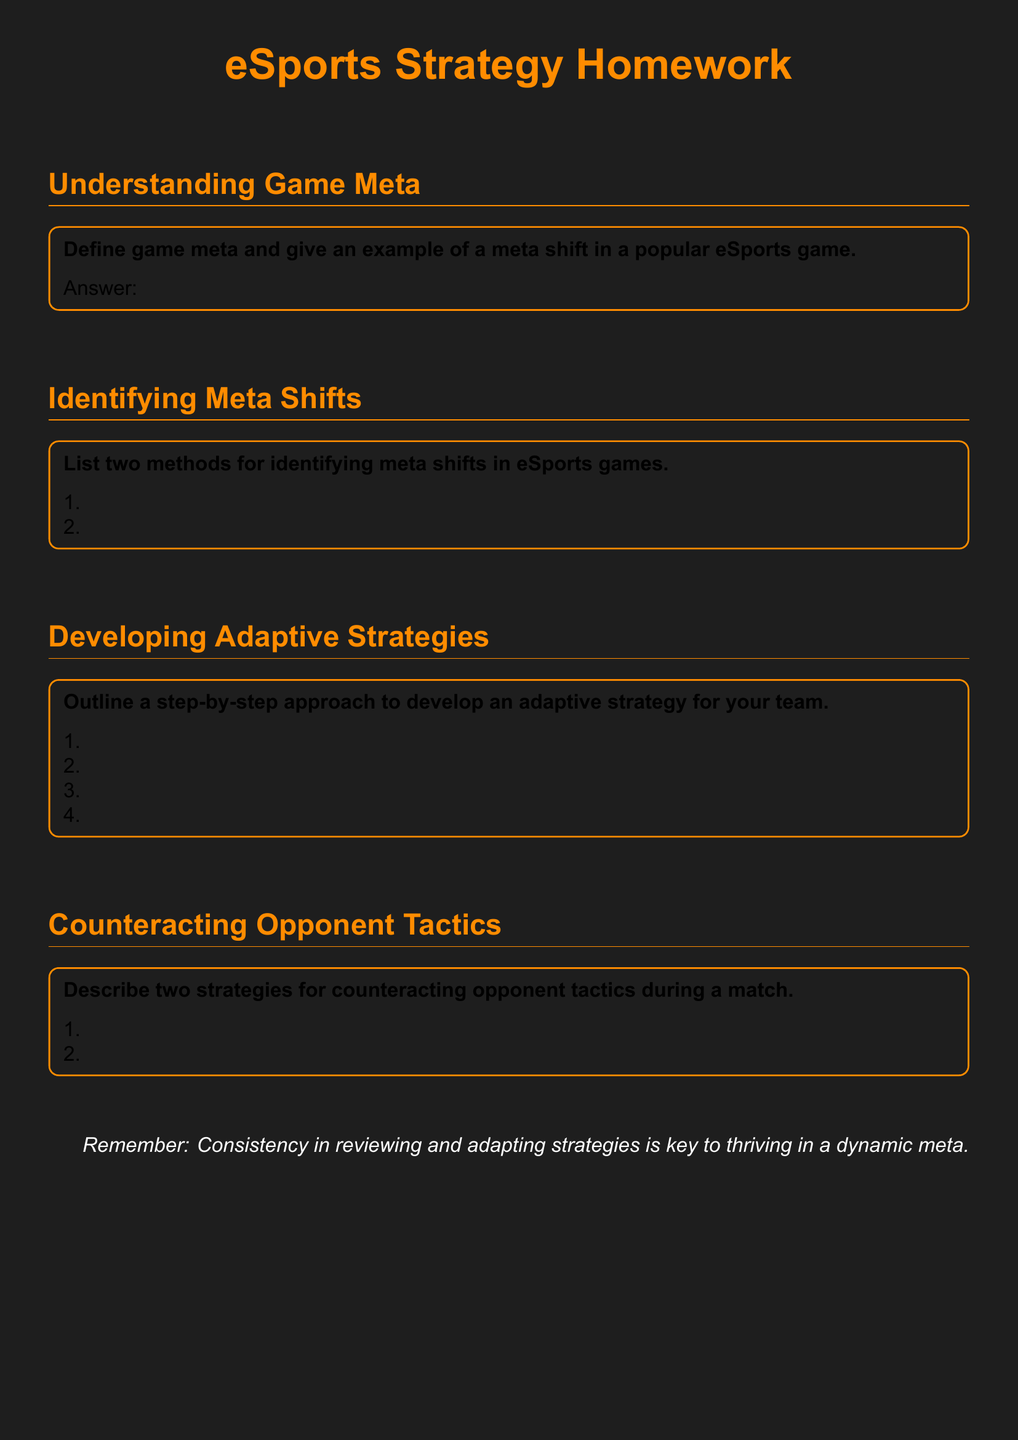What is the title of the document? The title of the document is presented prominently at the top and is "eSports Strategy Homework."
Answer: eSports Strategy Homework What color is the background of the document? The document indicates a specific RGB color for the background, which is (30, 30, 30).
Answer: Gamer gray What is one example of a section in the document? The document includes sections such as "Understanding Game Meta," "Identifying Meta Shifts," and others.
Answer: Understanding Game Meta How many methods for identifying meta shifts are listed? The document specifies two methods for identifying meta shifts, as indicated in the respective section.
Answer: Two What is the purpose of the last statement in the document? The last statement serves as a reminder about the importance of consistency in reviewing and adapting strategies in a dynamic meta.
Answer: Key to thriving in a dynamic meta What color is used for section titles? The section titles are colored in a specific RGB notation that corresponds to an orange shade.
Answer: Gamer accent What is the first step mentioned for developing an adaptive strategy? The first step listed for developing an adaptive strategy is outlined in the "Developing Adaptive Strategies" section.
Answer: Step 1 How many strategies for counteracting opponent tactics are described? The document specifically describes two strategies for counteracting opponent tactics.
Answer: Two What accent color is used for the text? The accent color used for the text in the document is an orange shade defined by its RGB value.
Answer: Gamer accent 